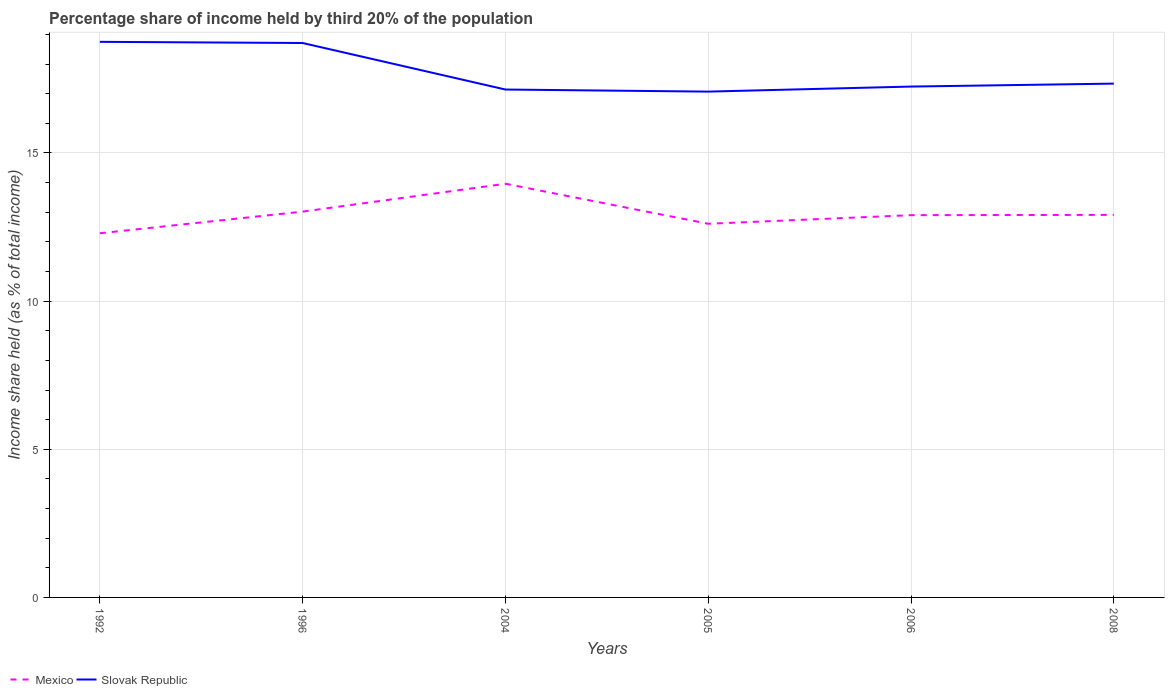How many different coloured lines are there?
Your answer should be very brief. 2. Does the line corresponding to Slovak Republic intersect with the line corresponding to Mexico?
Keep it short and to the point. No. Is the number of lines equal to the number of legend labels?
Provide a succinct answer. Yes. Across all years, what is the maximum share of income held by third 20% of the population in Slovak Republic?
Your answer should be compact. 17.07. In which year was the share of income held by third 20% of the population in Mexico maximum?
Offer a terse response. 1992. What is the total share of income held by third 20% of the population in Mexico in the graph?
Keep it short and to the point. -1.67. What is the difference between the highest and the second highest share of income held by third 20% of the population in Slovak Republic?
Provide a short and direct response. 1.68. How many lines are there?
Offer a terse response. 2. What is the difference between two consecutive major ticks on the Y-axis?
Keep it short and to the point. 5. Are the values on the major ticks of Y-axis written in scientific E-notation?
Offer a very short reply. No. Does the graph contain any zero values?
Provide a succinct answer. No. Does the graph contain grids?
Ensure brevity in your answer.  Yes. Where does the legend appear in the graph?
Offer a terse response. Bottom left. How many legend labels are there?
Provide a short and direct response. 2. How are the legend labels stacked?
Keep it short and to the point. Horizontal. What is the title of the graph?
Offer a very short reply. Percentage share of income held by third 20% of the population. Does "Fragile and conflict affected situations" appear as one of the legend labels in the graph?
Offer a terse response. No. What is the label or title of the X-axis?
Offer a terse response. Years. What is the label or title of the Y-axis?
Make the answer very short. Income share held (as % of total income). What is the Income share held (as % of total income) in Mexico in 1992?
Provide a succinct answer. 12.29. What is the Income share held (as % of total income) of Slovak Republic in 1992?
Provide a succinct answer. 18.75. What is the Income share held (as % of total income) in Mexico in 1996?
Your answer should be compact. 13.02. What is the Income share held (as % of total income) in Slovak Republic in 1996?
Ensure brevity in your answer.  18.71. What is the Income share held (as % of total income) of Mexico in 2004?
Offer a terse response. 13.96. What is the Income share held (as % of total income) of Slovak Republic in 2004?
Your answer should be compact. 17.14. What is the Income share held (as % of total income) of Mexico in 2005?
Keep it short and to the point. 12.61. What is the Income share held (as % of total income) in Slovak Republic in 2005?
Ensure brevity in your answer.  17.07. What is the Income share held (as % of total income) in Slovak Republic in 2006?
Ensure brevity in your answer.  17.24. What is the Income share held (as % of total income) of Mexico in 2008?
Provide a succinct answer. 12.91. What is the Income share held (as % of total income) in Slovak Republic in 2008?
Give a very brief answer. 17.34. Across all years, what is the maximum Income share held (as % of total income) of Mexico?
Your response must be concise. 13.96. Across all years, what is the maximum Income share held (as % of total income) in Slovak Republic?
Make the answer very short. 18.75. Across all years, what is the minimum Income share held (as % of total income) of Mexico?
Provide a succinct answer. 12.29. Across all years, what is the minimum Income share held (as % of total income) in Slovak Republic?
Provide a succinct answer. 17.07. What is the total Income share held (as % of total income) of Mexico in the graph?
Your answer should be very brief. 77.69. What is the total Income share held (as % of total income) of Slovak Republic in the graph?
Offer a very short reply. 106.25. What is the difference between the Income share held (as % of total income) of Mexico in 1992 and that in 1996?
Your answer should be compact. -0.73. What is the difference between the Income share held (as % of total income) of Mexico in 1992 and that in 2004?
Your answer should be very brief. -1.67. What is the difference between the Income share held (as % of total income) in Slovak Republic in 1992 and that in 2004?
Your answer should be very brief. 1.61. What is the difference between the Income share held (as % of total income) in Mexico in 1992 and that in 2005?
Your answer should be very brief. -0.32. What is the difference between the Income share held (as % of total income) of Slovak Republic in 1992 and that in 2005?
Offer a very short reply. 1.68. What is the difference between the Income share held (as % of total income) in Mexico in 1992 and that in 2006?
Offer a very short reply. -0.61. What is the difference between the Income share held (as % of total income) of Slovak Republic in 1992 and that in 2006?
Keep it short and to the point. 1.51. What is the difference between the Income share held (as % of total income) of Mexico in 1992 and that in 2008?
Offer a terse response. -0.62. What is the difference between the Income share held (as % of total income) in Slovak Republic in 1992 and that in 2008?
Your answer should be compact. 1.41. What is the difference between the Income share held (as % of total income) of Mexico in 1996 and that in 2004?
Offer a terse response. -0.94. What is the difference between the Income share held (as % of total income) of Slovak Republic in 1996 and that in 2004?
Provide a succinct answer. 1.57. What is the difference between the Income share held (as % of total income) in Mexico in 1996 and that in 2005?
Make the answer very short. 0.41. What is the difference between the Income share held (as % of total income) of Slovak Republic in 1996 and that in 2005?
Keep it short and to the point. 1.64. What is the difference between the Income share held (as % of total income) in Mexico in 1996 and that in 2006?
Keep it short and to the point. 0.12. What is the difference between the Income share held (as % of total income) of Slovak Republic in 1996 and that in 2006?
Make the answer very short. 1.47. What is the difference between the Income share held (as % of total income) of Mexico in 1996 and that in 2008?
Provide a short and direct response. 0.11. What is the difference between the Income share held (as % of total income) of Slovak Republic in 1996 and that in 2008?
Keep it short and to the point. 1.37. What is the difference between the Income share held (as % of total income) in Mexico in 2004 and that in 2005?
Your response must be concise. 1.35. What is the difference between the Income share held (as % of total income) of Slovak Republic in 2004 and that in 2005?
Offer a terse response. 0.07. What is the difference between the Income share held (as % of total income) of Mexico in 2004 and that in 2006?
Make the answer very short. 1.06. What is the difference between the Income share held (as % of total income) of Slovak Republic in 2004 and that in 2008?
Your answer should be very brief. -0.2. What is the difference between the Income share held (as % of total income) in Mexico in 2005 and that in 2006?
Your answer should be very brief. -0.29. What is the difference between the Income share held (as % of total income) in Slovak Republic in 2005 and that in 2006?
Ensure brevity in your answer.  -0.17. What is the difference between the Income share held (as % of total income) in Mexico in 2005 and that in 2008?
Ensure brevity in your answer.  -0.3. What is the difference between the Income share held (as % of total income) of Slovak Republic in 2005 and that in 2008?
Provide a short and direct response. -0.27. What is the difference between the Income share held (as % of total income) in Mexico in 2006 and that in 2008?
Give a very brief answer. -0.01. What is the difference between the Income share held (as % of total income) in Mexico in 1992 and the Income share held (as % of total income) in Slovak Republic in 1996?
Your answer should be very brief. -6.42. What is the difference between the Income share held (as % of total income) of Mexico in 1992 and the Income share held (as % of total income) of Slovak Republic in 2004?
Provide a succinct answer. -4.85. What is the difference between the Income share held (as % of total income) of Mexico in 1992 and the Income share held (as % of total income) of Slovak Republic in 2005?
Offer a very short reply. -4.78. What is the difference between the Income share held (as % of total income) in Mexico in 1992 and the Income share held (as % of total income) in Slovak Republic in 2006?
Your response must be concise. -4.95. What is the difference between the Income share held (as % of total income) of Mexico in 1992 and the Income share held (as % of total income) of Slovak Republic in 2008?
Your response must be concise. -5.05. What is the difference between the Income share held (as % of total income) in Mexico in 1996 and the Income share held (as % of total income) in Slovak Republic in 2004?
Make the answer very short. -4.12. What is the difference between the Income share held (as % of total income) of Mexico in 1996 and the Income share held (as % of total income) of Slovak Republic in 2005?
Your answer should be very brief. -4.05. What is the difference between the Income share held (as % of total income) of Mexico in 1996 and the Income share held (as % of total income) of Slovak Republic in 2006?
Make the answer very short. -4.22. What is the difference between the Income share held (as % of total income) of Mexico in 1996 and the Income share held (as % of total income) of Slovak Republic in 2008?
Keep it short and to the point. -4.32. What is the difference between the Income share held (as % of total income) in Mexico in 2004 and the Income share held (as % of total income) in Slovak Republic in 2005?
Your answer should be compact. -3.11. What is the difference between the Income share held (as % of total income) of Mexico in 2004 and the Income share held (as % of total income) of Slovak Republic in 2006?
Offer a terse response. -3.28. What is the difference between the Income share held (as % of total income) of Mexico in 2004 and the Income share held (as % of total income) of Slovak Republic in 2008?
Provide a short and direct response. -3.38. What is the difference between the Income share held (as % of total income) in Mexico in 2005 and the Income share held (as % of total income) in Slovak Republic in 2006?
Your answer should be compact. -4.63. What is the difference between the Income share held (as % of total income) of Mexico in 2005 and the Income share held (as % of total income) of Slovak Republic in 2008?
Offer a very short reply. -4.73. What is the difference between the Income share held (as % of total income) of Mexico in 2006 and the Income share held (as % of total income) of Slovak Republic in 2008?
Offer a terse response. -4.44. What is the average Income share held (as % of total income) of Mexico per year?
Your response must be concise. 12.95. What is the average Income share held (as % of total income) of Slovak Republic per year?
Offer a very short reply. 17.71. In the year 1992, what is the difference between the Income share held (as % of total income) in Mexico and Income share held (as % of total income) in Slovak Republic?
Keep it short and to the point. -6.46. In the year 1996, what is the difference between the Income share held (as % of total income) of Mexico and Income share held (as % of total income) of Slovak Republic?
Offer a terse response. -5.69. In the year 2004, what is the difference between the Income share held (as % of total income) of Mexico and Income share held (as % of total income) of Slovak Republic?
Provide a short and direct response. -3.18. In the year 2005, what is the difference between the Income share held (as % of total income) in Mexico and Income share held (as % of total income) in Slovak Republic?
Your answer should be compact. -4.46. In the year 2006, what is the difference between the Income share held (as % of total income) of Mexico and Income share held (as % of total income) of Slovak Republic?
Ensure brevity in your answer.  -4.34. In the year 2008, what is the difference between the Income share held (as % of total income) in Mexico and Income share held (as % of total income) in Slovak Republic?
Provide a short and direct response. -4.43. What is the ratio of the Income share held (as % of total income) in Mexico in 1992 to that in 1996?
Offer a very short reply. 0.94. What is the ratio of the Income share held (as % of total income) of Slovak Republic in 1992 to that in 1996?
Offer a very short reply. 1. What is the ratio of the Income share held (as % of total income) in Mexico in 1992 to that in 2004?
Give a very brief answer. 0.88. What is the ratio of the Income share held (as % of total income) in Slovak Republic in 1992 to that in 2004?
Keep it short and to the point. 1.09. What is the ratio of the Income share held (as % of total income) of Mexico in 1992 to that in 2005?
Keep it short and to the point. 0.97. What is the ratio of the Income share held (as % of total income) in Slovak Republic in 1992 to that in 2005?
Ensure brevity in your answer.  1.1. What is the ratio of the Income share held (as % of total income) in Mexico in 1992 to that in 2006?
Your answer should be very brief. 0.95. What is the ratio of the Income share held (as % of total income) of Slovak Republic in 1992 to that in 2006?
Make the answer very short. 1.09. What is the ratio of the Income share held (as % of total income) of Mexico in 1992 to that in 2008?
Your answer should be very brief. 0.95. What is the ratio of the Income share held (as % of total income) in Slovak Republic in 1992 to that in 2008?
Give a very brief answer. 1.08. What is the ratio of the Income share held (as % of total income) of Mexico in 1996 to that in 2004?
Keep it short and to the point. 0.93. What is the ratio of the Income share held (as % of total income) in Slovak Republic in 1996 to that in 2004?
Ensure brevity in your answer.  1.09. What is the ratio of the Income share held (as % of total income) of Mexico in 1996 to that in 2005?
Keep it short and to the point. 1.03. What is the ratio of the Income share held (as % of total income) in Slovak Republic in 1996 to that in 2005?
Offer a very short reply. 1.1. What is the ratio of the Income share held (as % of total income) in Mexico in 1996 to that in 2006?
Provide a short and direct response. 1.01. What is the ratio of the Income share held (as % of total income) in Slovak Republic in 1996 to that in 2006?
Your response must be concise. 1.09. What is the ratio of the Income share held (as % of total income) of Mexico in 1996 to that in 2008?
Keep it short and to the point. 1.01. What is the ratio of the Income share held (as % of total income) of Slovak Republic in 1996 to that in 2008?
Offer a very short reply. 1.08. What is the ratio of the Income share held (as % of total income) of Mexico in 2004 to that in 2005?
Your answer should be very brief. 1.11. What is the ratio of the Income share held (as % of total income) of Slovak Republic in 2004 to that in 2005?
Offer a terse response. 1. What is the ratio of the Income share held (as % of total income) in Mexico in 2004 to that in 2006?
Your answer should be very brief. 1.08. What is the ratio of the Income share held (as % of total income) in Slovak Republic in 2004 to that in 2006?
Your answer should be compact. 0.99. What is the ratio of the Income share held (as % of total income) in Mexico in 2004 to that in 2008?
Provide a succinct answer. 1.08. What is the ratio of the Income share held (as % of total income) of Mexico in 2005 to that in 2006?
Ensure brevity in your answer.  0.98. What is the ratio of the Income share held (as % of total income) of Mexico in 2005 to that in 2008?
Keep it short and to the point. 0.98. What is the ratio of the Income share held (as % of total income) of Slovak Republic in 2005 to that in 2008?
Give a very brief answer. 0.98. What is the difference between the highest and the lowest Income share held (as % of total income) of Mexico?
Your answer should be compact. 1.67. What is the difference between the highest and the lowest Income share held (as % of total income) of Slovak Republic?
Provide a short and direct response. 1.68. 